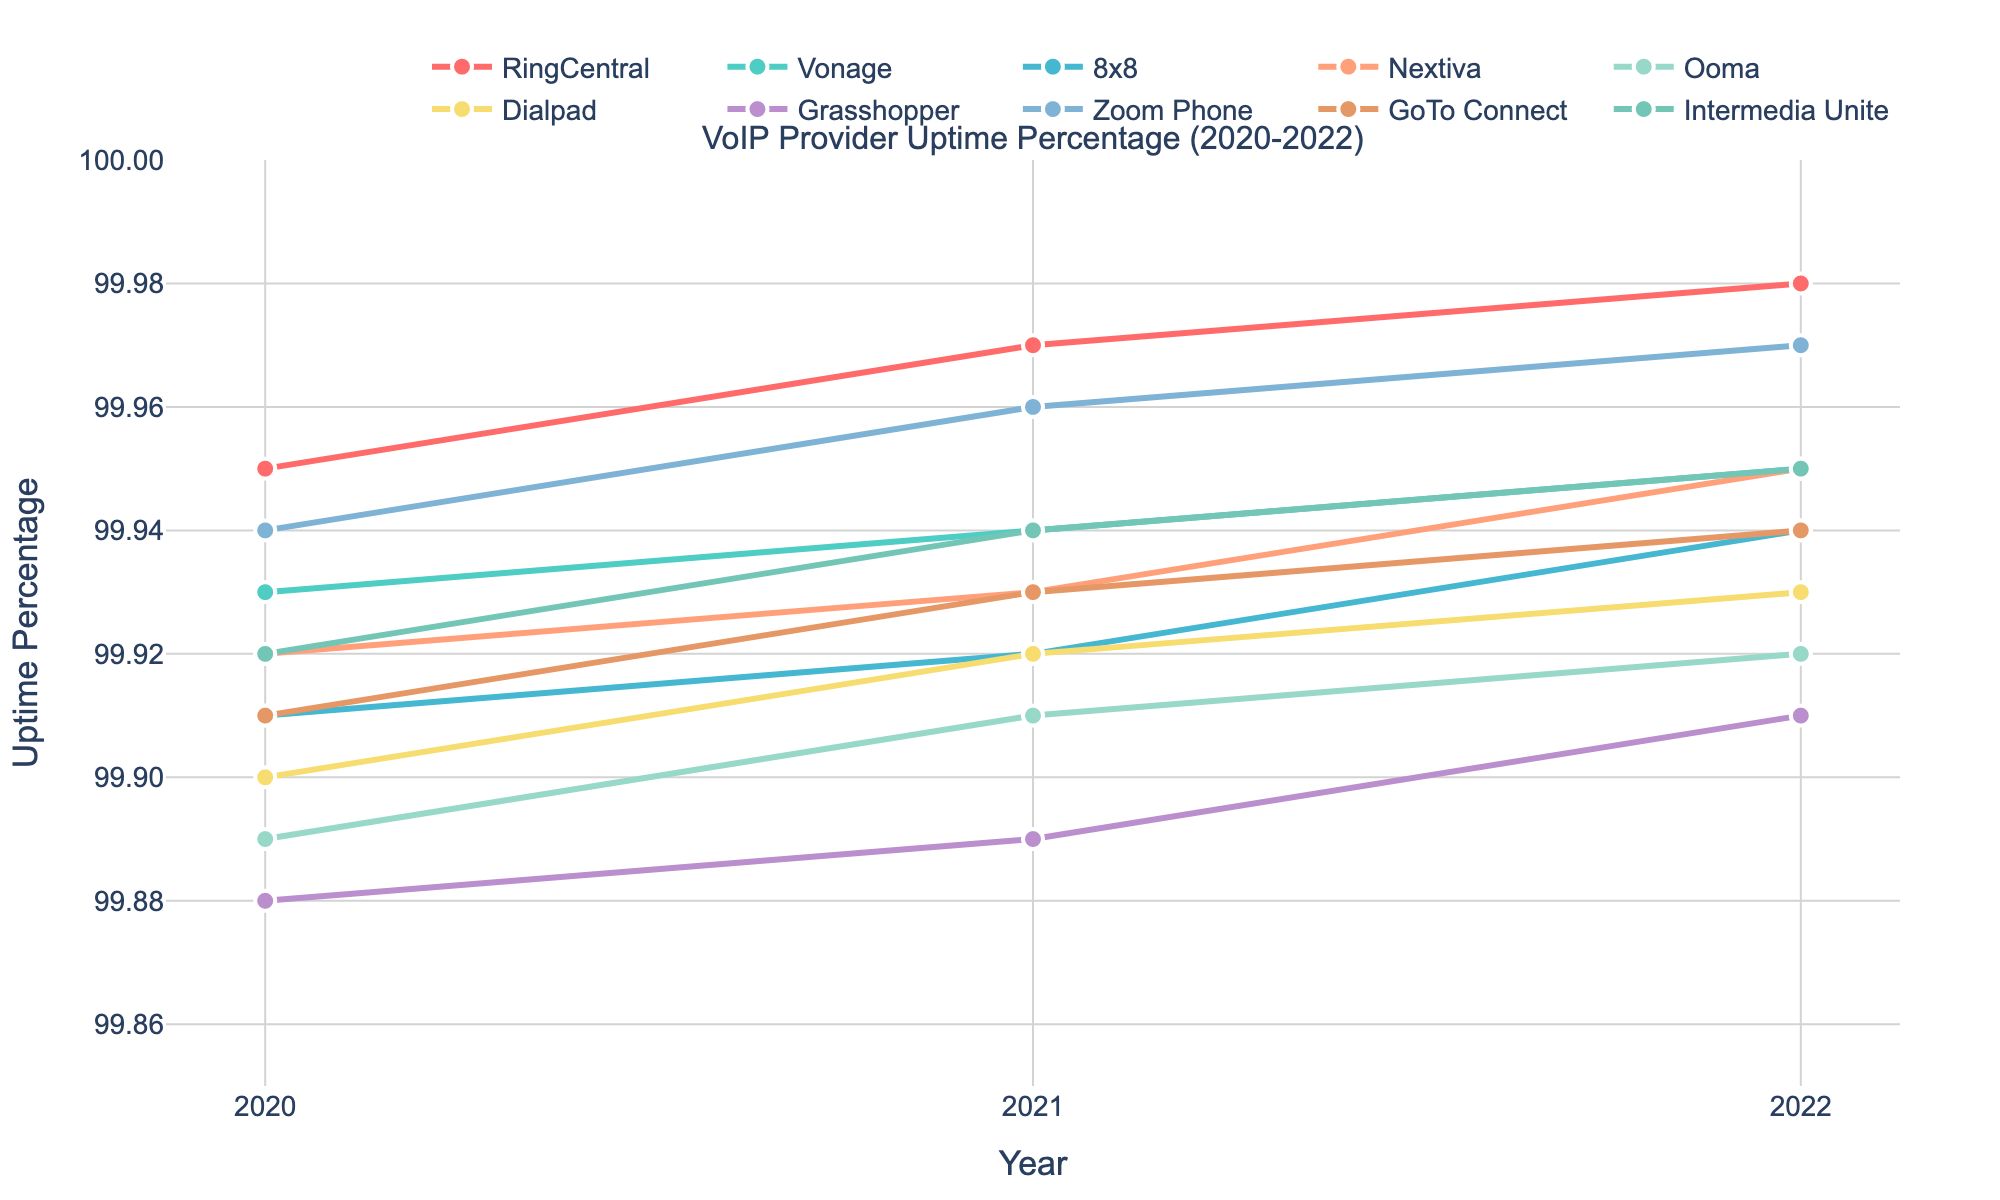What is the highest average uptime percentage for any provider in 2022? Identify the 2022 uptime percentages for all providers: 99.98 (RingCentral), 99.95 (Vonage), 99.94 (8x8), 99.95 (Nextiva), 99.92 (Ooma), 99.93 (Dialpad), 99.91 (Grasshopper), 99.97 (Zoom Phone), 99.94 (GoTo Connect), and 99.95 (Intermedia Unite). The highest value is 99.98 for RingCentral.
Answer: 99.98 Which provider had the most consistent (least variable) uptime performance over the 3 years? Evaluate the consistency of uptime percentages by checking the variability (changes over years). RingCentral had percentages of 99.95, 99.97, and 99.98, which is the smallest range (0.03).
Answer: RingCentral How many providers had an uptime percentage of at least 99.95% in 2022? Review the 2022 uptime percentages: RingCentral (99.98), Vonage (99.95), 8x8 (99.94), Nextiva (99.95), Ooma (99.92), Dialpad (99.93), Grasshopper (99.91), Zoom Phone (99.97), GoTo Connect (99.94), and Intermedia Unite (99.95). Count those with at least 99.95%: RingCentral, Vonage, Nextiva, Zoom Phone, and Intermedia Unite (5 providers).
Answer: 5 Which provider had the lowest improvement in uptime percentage from 2020 to 2022? Calculate the difference from 2020 to 2022 for each provider: RingCentral (0.03), Vonage (0.02), 8x8 (0.03), Nextiva (0.03), Ooma (0.03), Dialpad (0.03), Grasshopper (0.03), Zoom Phone (0.03), GoTo Connect (0.03), and Intermedia Unite (0.03). Vonage had the smallest improvement (0.02).
Answer: Vonage Which provider had the highest uptick in uptime percentage from 2021 to 2022? Find the differences from 2021 to 2022 for each provider: RingCentral (0.01), Vonage (0.01), 8x8 (0.02), Nextiva (0.02), Ooma (0.01), Dialpad (0.01), Grasshopper (0.02), Zoom Phone (0.01), GoTo Connect (0.01), and Intermedia Unite (0.01). The highest uptick is for 8x8 and Grasshopper (0.02).
Answer: 8x8, Grasshopper Which provider showed a steady increase in uptime percentage every year from 2020 to 2022? Check if each provider's uptime increased each year: RingCentral (99.95 to 99.97 to 99.98), Vonage (99.93 to 99.94 to 99.95), 8x8 (99.91 to 99.92 to 99.94), Nextiva (99.92 to 99.93 to 99.95), Ooma (99.89 to 99.91 to 99.92), Dialpad (99.90 to 99.92 to 99.93), Grasshopper (99.88 to 99.89 to 99.91), Zoom Phone (99.94 to 99.96 to 99.97), GoTo Connect (99.91 to 99.93 to 99.94), Intermedia Unite (99.92 to 99.94 to 99.95). All providers increased steadily.
Answer: All What is the average uptime percentage of GoTo Connect over the 3 years? Find the average by summing GoTo Connect's percentages (99.91, 99.93, 99.94) and dividing by 3. (99.91 + 99.93 + 99.94) / 3 = 99.9267.
Answer: 99.93 Which provider had the lowest uptime percentage recorded in 2021? Identify the 2021 percentages: RingCentral (99.97), Vonage (99.94), 8x8 (99.92), Nextiva (99.93), Ooma (99.91), Dialpad (99.92), Grasshopper (99.89), Zoom Phone (99.96), GoTo Connect (99.93), and Intermedia Unite (99.94). The lowest is Grasshopper (99.89).
Answer: Grasshopper 